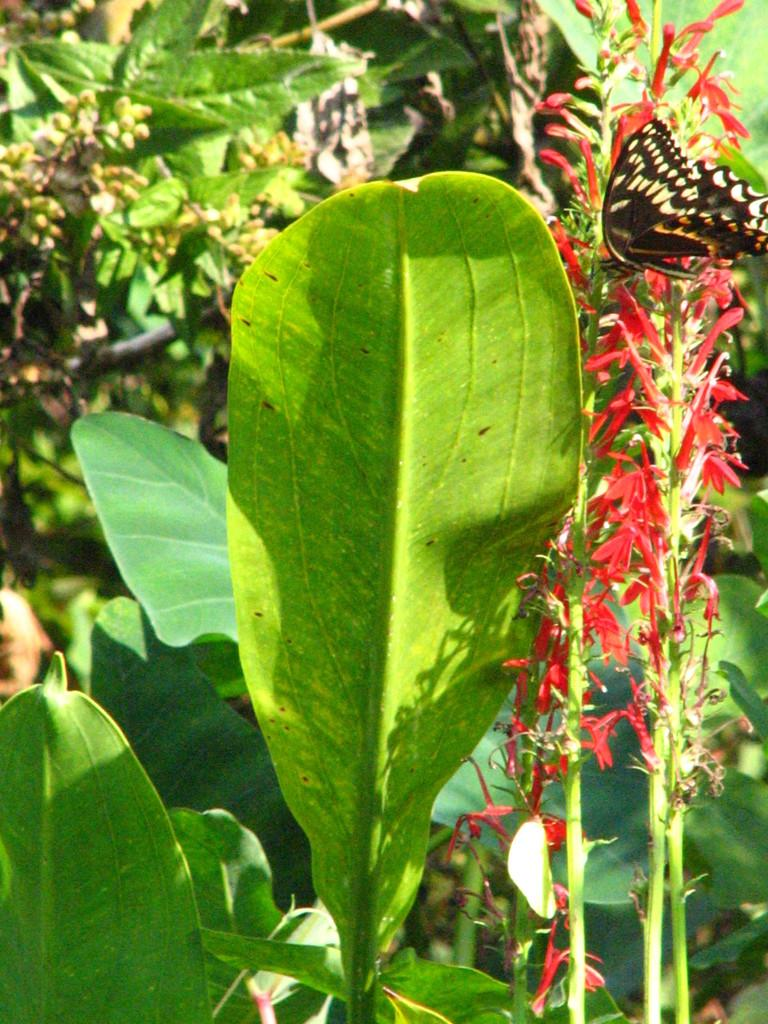What type of natural elements can be seen in the image? There are many plant leaves, a butterfly, and flowers in the image. Can you describe the butterfly in the image? Yes, there is a butterfly in the image. What other types of plants are visible in the image besides leaves? Flowers are also visible in the image. What type of family can be seen in the image? There is no family present in the image; it features plant leaves, a butterfly, and flowers. What type of vessel is used to hold the butterfly in the image? There is no vessel holding the butterfly in the image; it is flying freely. 